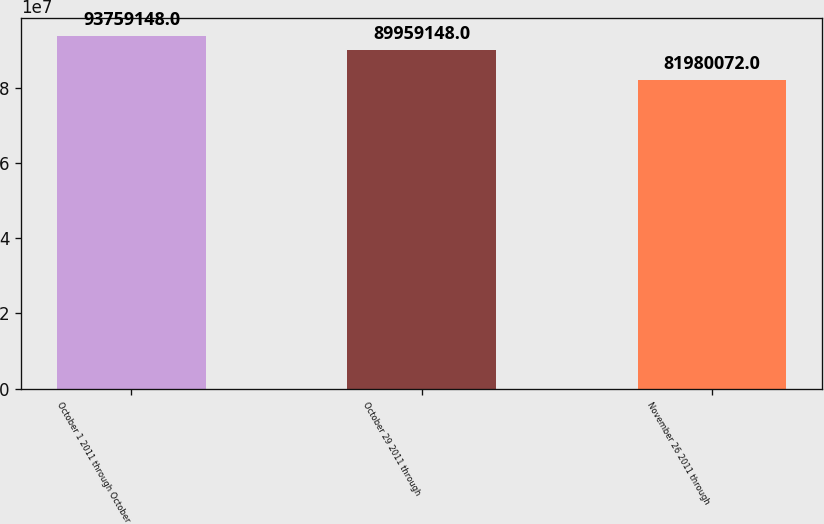<chart> <loc_0><loc_0><loc_500><loc_500><bar_chart><fcel>October 1 2011 through October<fcel>October 29 2011 through<fcel>November 26 2011 through<nl><fcel>9.37591e+07<fcel>8.99591e+07<fcel>8.19801e+07<nl></chart> 